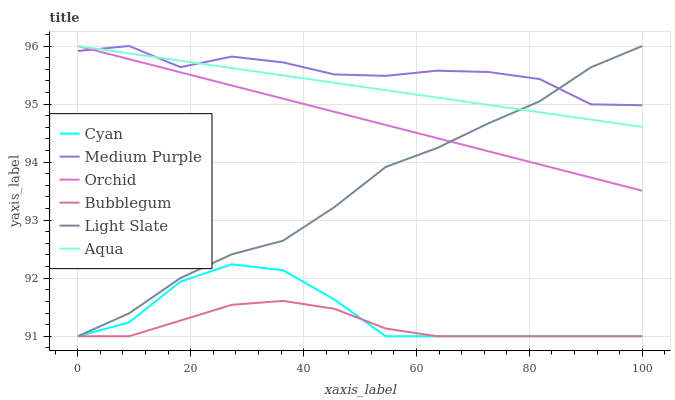Does Bubblegum have the minimum area under the curve?
Answer yes or no. Yes. Does Medium Purple have the maximum area under the curve?
Answer yes or no. Yes. Does Aqua have the minimum area under the curve?
Answer yes or no. No. Does Aqua have the maximum area under the curve?
Answer yes or no. No. Is Aqua the smoothest?
Answer yes or no. Yes. Is Medium Purple the roughest?
Answer yes or no. Yes. Is Bubblegum the smoothest?
Answer yes or no. No. Is Bubblegum the roughest?
Answer yes or no. No. Does Aqua have the lowest value?
Answer yes or no. No. Does Orchid have the highest value?
Answer yes or no. Yes. Does Bubblegum have the highest value?
Answer yes or no. No. Is Cyan less than Orchid?
Answer yes or no. Yes. Is Aqua greater than Bubblegum?
Answer yes or no. Yes. Does Light Slate intersect Aqua?
Answer yes or no. Yes. Is Light Slate less than Aqua?
Answer yes or no. No. Is Light Slate greater than Aqua?
Answer yes or no. No. Does Cyan intersect Orchid?
Answer yes or no. No. 